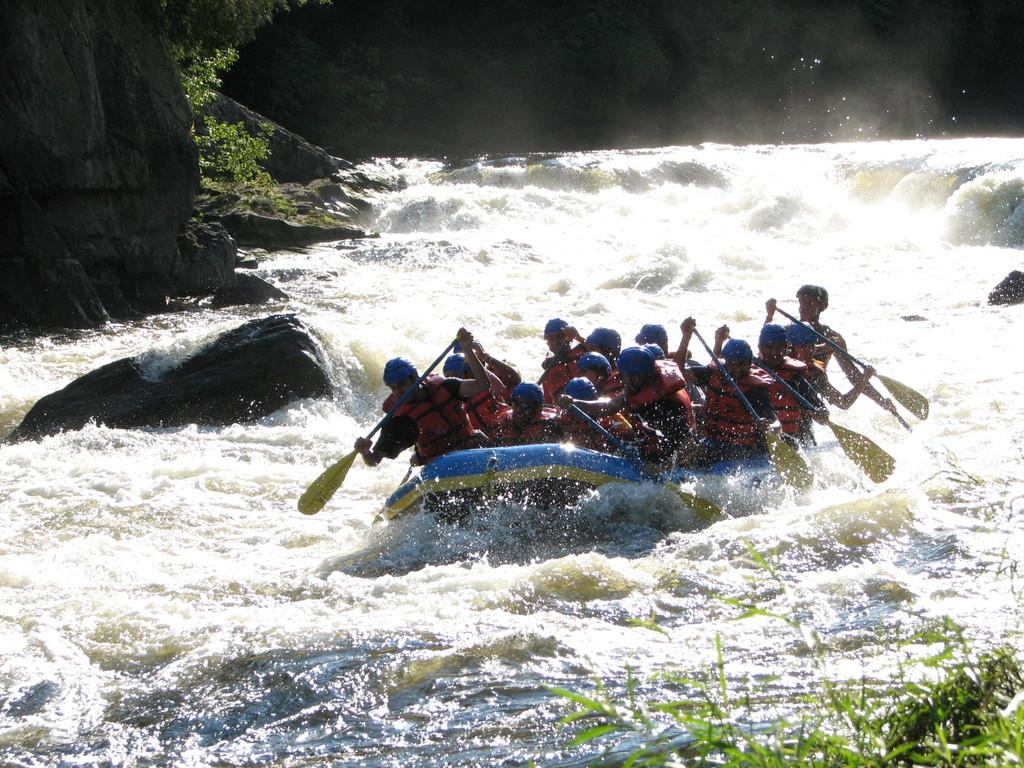What activity are the people in the image engaged in? The people in the image are rafting. What type of environment can be seen in the image? There is water with stones, grass, hills, and plants visible in the image. Can you find the locket hanging from the tree in the image? There is no locket present in the image. What type of brass object can be seen in the water? There is no brass object present in the image. 